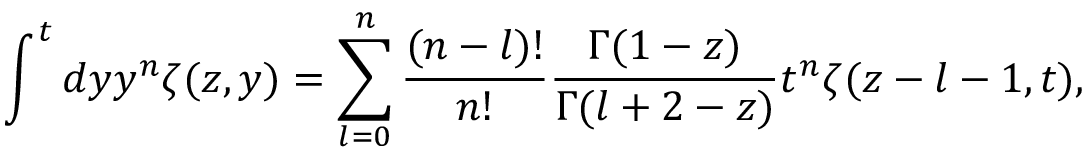Convert formula to latex. <formula><loc_0><loc_0><loc_500><loc_500>\int ^ { t } d y y ^ { n } \zeta ( z , y ) = \sum _ { l = 0 } ^ { n } \frac { ( n - l ) ! } { n ! } \frac { \Gamma ( 1 - z ) } { \Gamma ( l + 2 - z ) } t ^ { n } \zeta ( z - l - 1 , t ) ,</formula> 